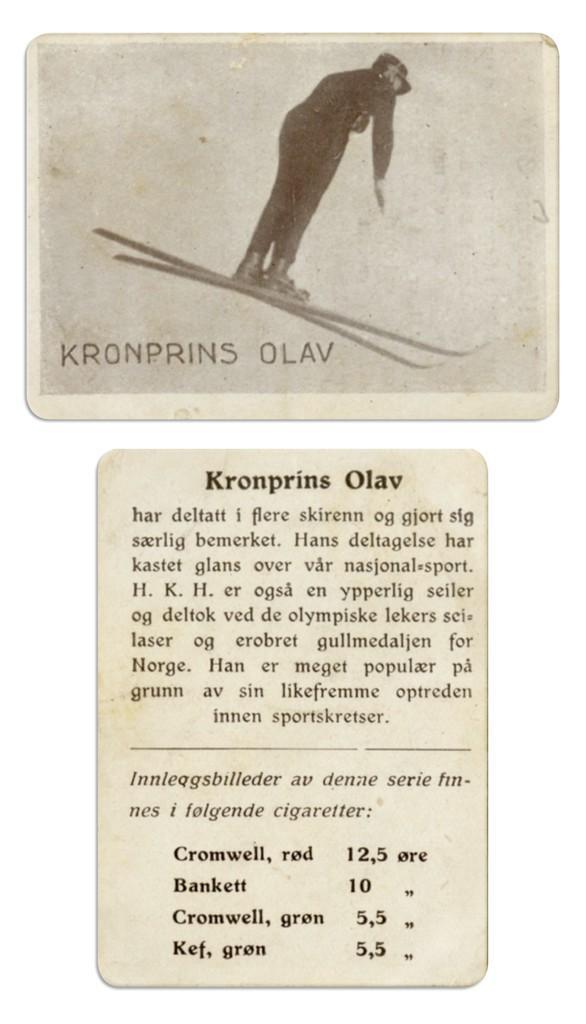How would you summarize this image in a sentence or two? These are the two papers. I can see the picture of the man standing with the ski boards. These are the letters and numbers on the paper. 